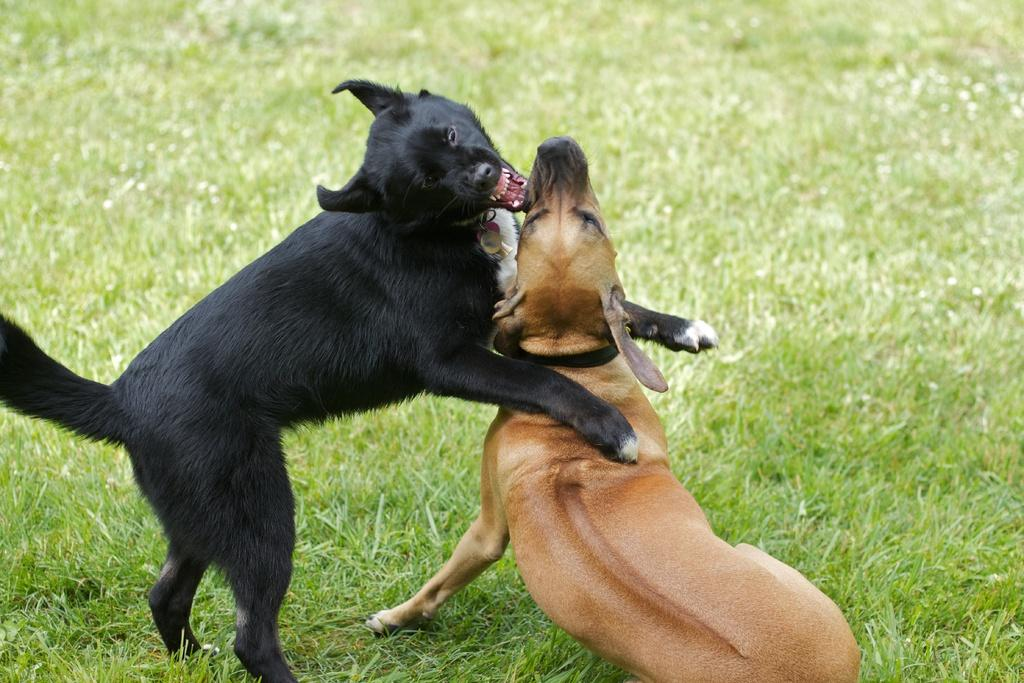What type of animal can be seen in the image? There is a black dog in the image. What is the black dog doing in the image? The black dog has placed its first two legs on another dog. What is the color of the other dog in the image? The other dog is brown in color. What can be seen on the ground in the image? The ground in the image has greenery. What type of receipt can be seen in the image? There is no receipt present in the image. 